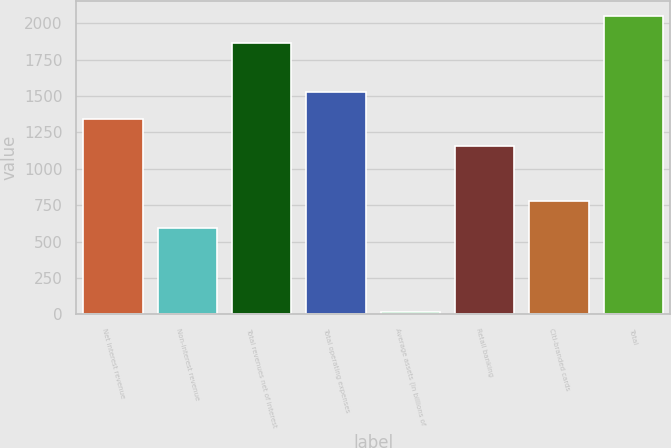Convert chart. <chart><loc_0><loc_0><loc_500><loc_500><bar_chart><fcel>Net interest revenue<fcel>Non-interest revenue<fcel>Total revenues net of interest<fcel>Total operating expenses<fcel>Average assets (in billions of<fcel>Retail banking<fcel>Citi-branded cards<fcel>Total<nl><fcel>1345.2<fcel>596<fcel>1865<fcel>1530.4<fcel>13<fcel>1160<fcel>781.2<fcel>2050.2<nl></chart> 